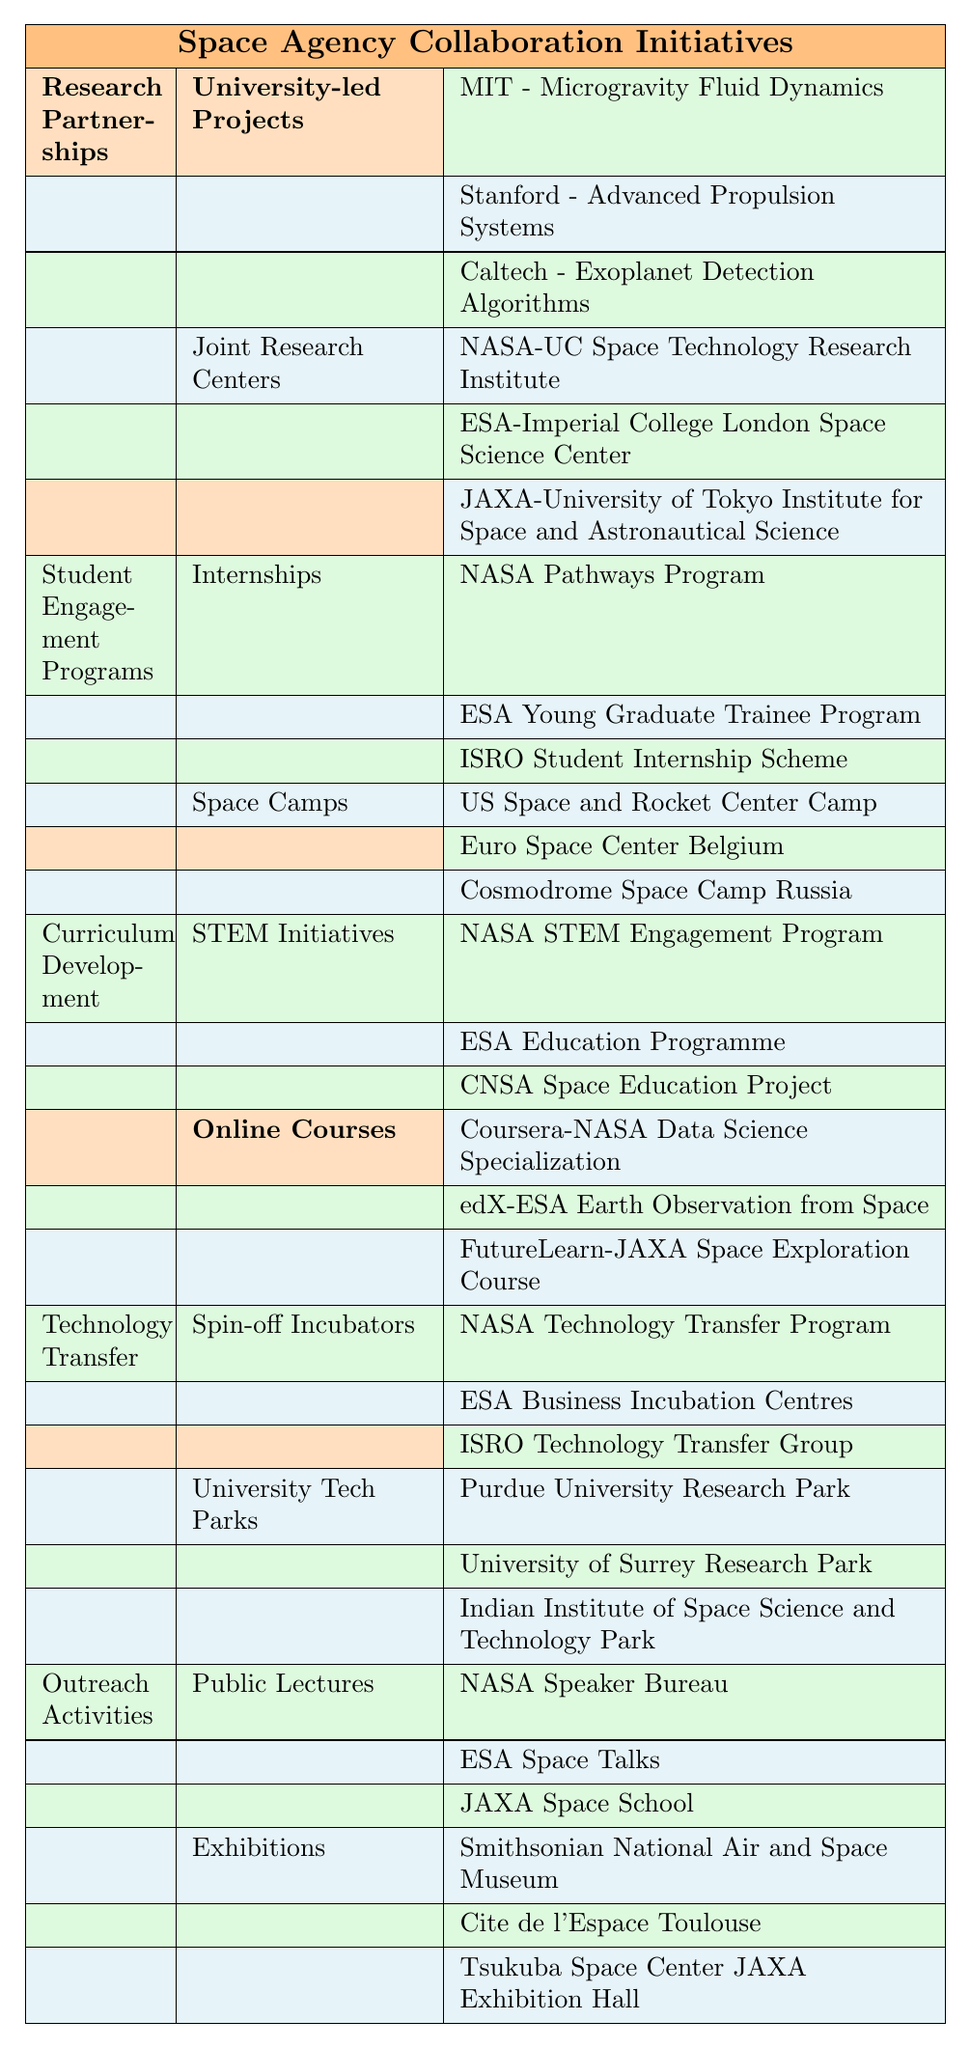What are the three main categories of collaboration initiatives by the space agency? The table lists five main categories: Research Partnerships, Student Engagement Programs, Curriculum Development, Technology Transfer, and Outreach Activities.
Answer: Research Partnerships, Student Engagement Programs, Curriculum Development Which university is associated with the project on Exoplanet Detection Algorithms? The project on Exoplanet Detection Algorithms is listed under the University-led Projects section, and it is associated with Caltech.
Answer: Caltech How many types of Student Engagement Programs are featured in the table? There are two types of Student Engagement Programs: Internships and Space Camps.
Answer: 2 Is the ESA Young Graduate Trainee Program an internship program? The table categorizes the ESA Young Graduate Trainee Program under Internships, confirming that it is indeed an internship program.
Answer: Yes Among the online courses listed, which agency is involved with the Data Science Specialization? The course titled "Coursera-NASA Data Science Specialization" indicates that NASA is involved in this online course.
Answer: NASA Count the total number of research projects listed under University-led Projects. Three projects are listed under University-led Projects: Microgravity Fluid Dynamics, Advanced Propulsion Systems, and Exoplanet Detection Algorithms.
Answer: 3 Are there more Spin-off Incubators or University Tech Parks listed in the table? There are three Spin-off Incubators and three University Tech Parks. Since they are equal, this means neither category has more entries.
Answer: Neither Which outreach activity has more items listed: Public Lectures or Exhibitions? Public Lectures list three items, and Exhibitions also list three items. Therefore, both outreach activities have the same number of items.
Answer: They are equal What is the relationship between NASA and the Coursera course? The table shows that NASA is involved in the "Coursera-NASA Data Science Specialization," indicating a direct relationship.
Answer: Collaboration on the course If you count all the different activities mentioned in the table, how many activities are there in total? Counting the initiatives, we have 3 projects under Research Partnerships, 6 under Student Engagement Programs, 6 under Curriculum Development, 6 under Technology Transfer, and 6 under Outreach Activities, totaling 27 activities.
Answer: 27 